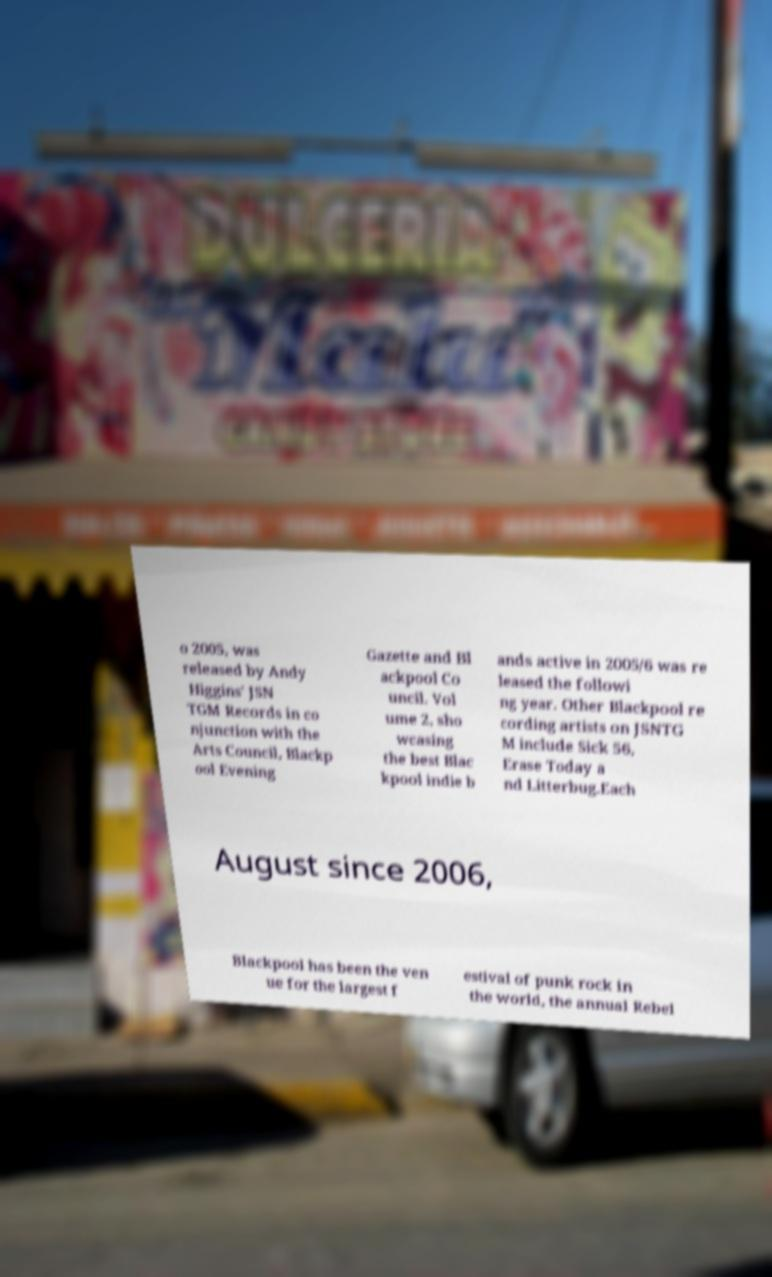Could you extract and type out the text from this image? o 2005, was released by Andy Higgins' JSN TGM Records in co njunction with the Arts Council, Blackp ool Evening Gazette and Bl ackpool Co uncil. Vol ume 2, sho wcasing the best Blac kpool indie b ands active in 2005/6 was re leased the followi ng year. Other Blackpool re cording artists on JSNTG M include Sick 56, Erase Today a nd Litterbug.Each August since 2006, Blackpool has been the ven ue for the largest f estival of punk rock in the world, the annual Rebel 